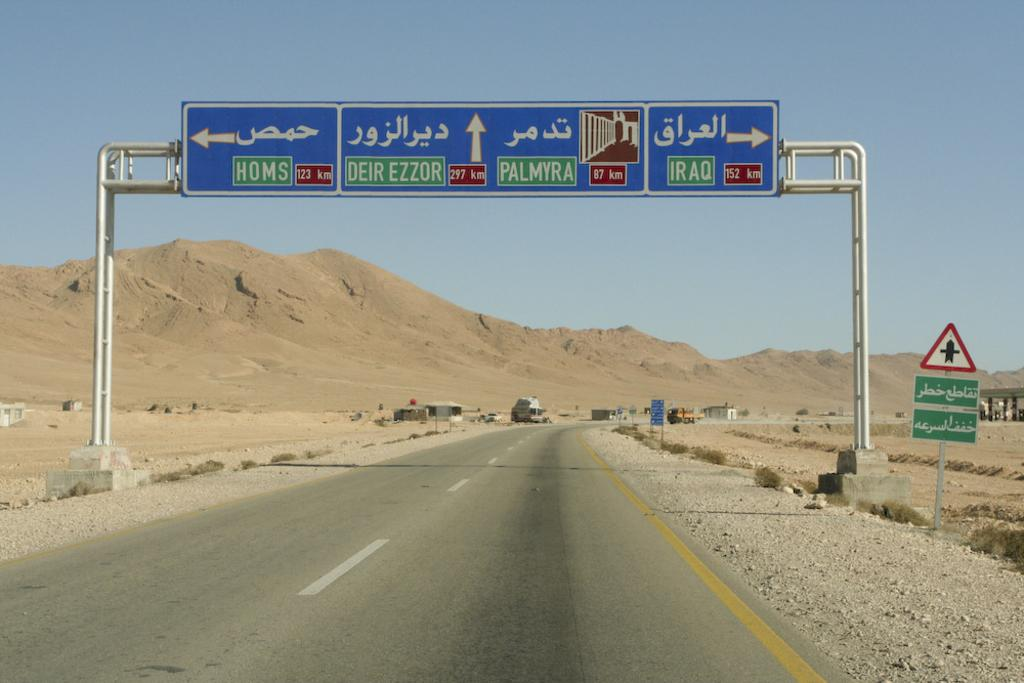<image>
Describe the image concisely. One of the street signs is pointing towards Homs 